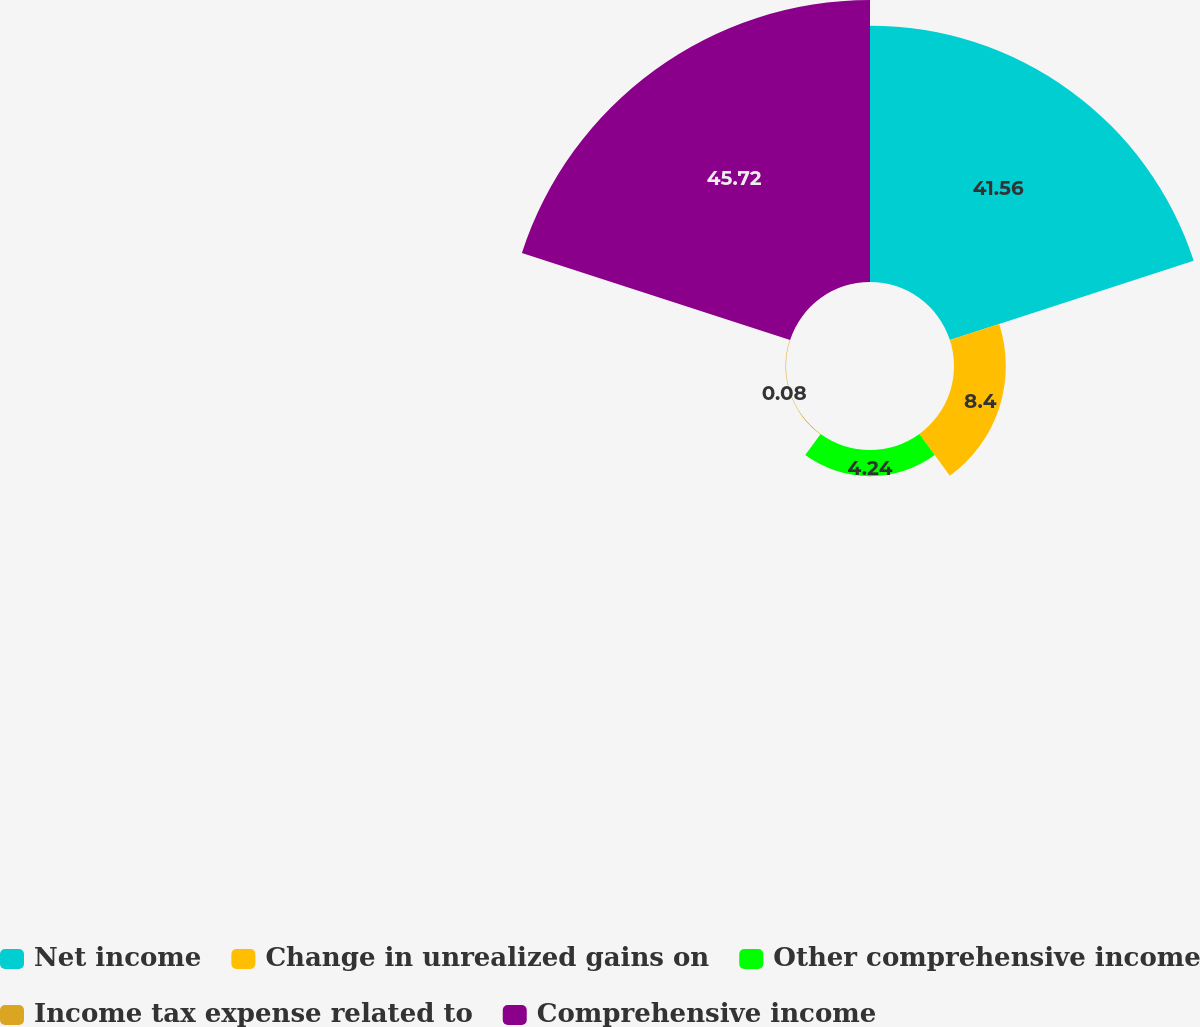<chart> <loc_0><loc_0><loc_500><loc_500><pie_chart><fcel>Net income<fcel>Change in unrealized gains on<fcel>Other comprehensive income<fcel>Income tax expense related to<fcel>Comprehensive income<nl><fcel>41.56%<fcel>8.4%<fcel>4.24%<fcel>0.08%<fcel>45.72%<nl></chart> 